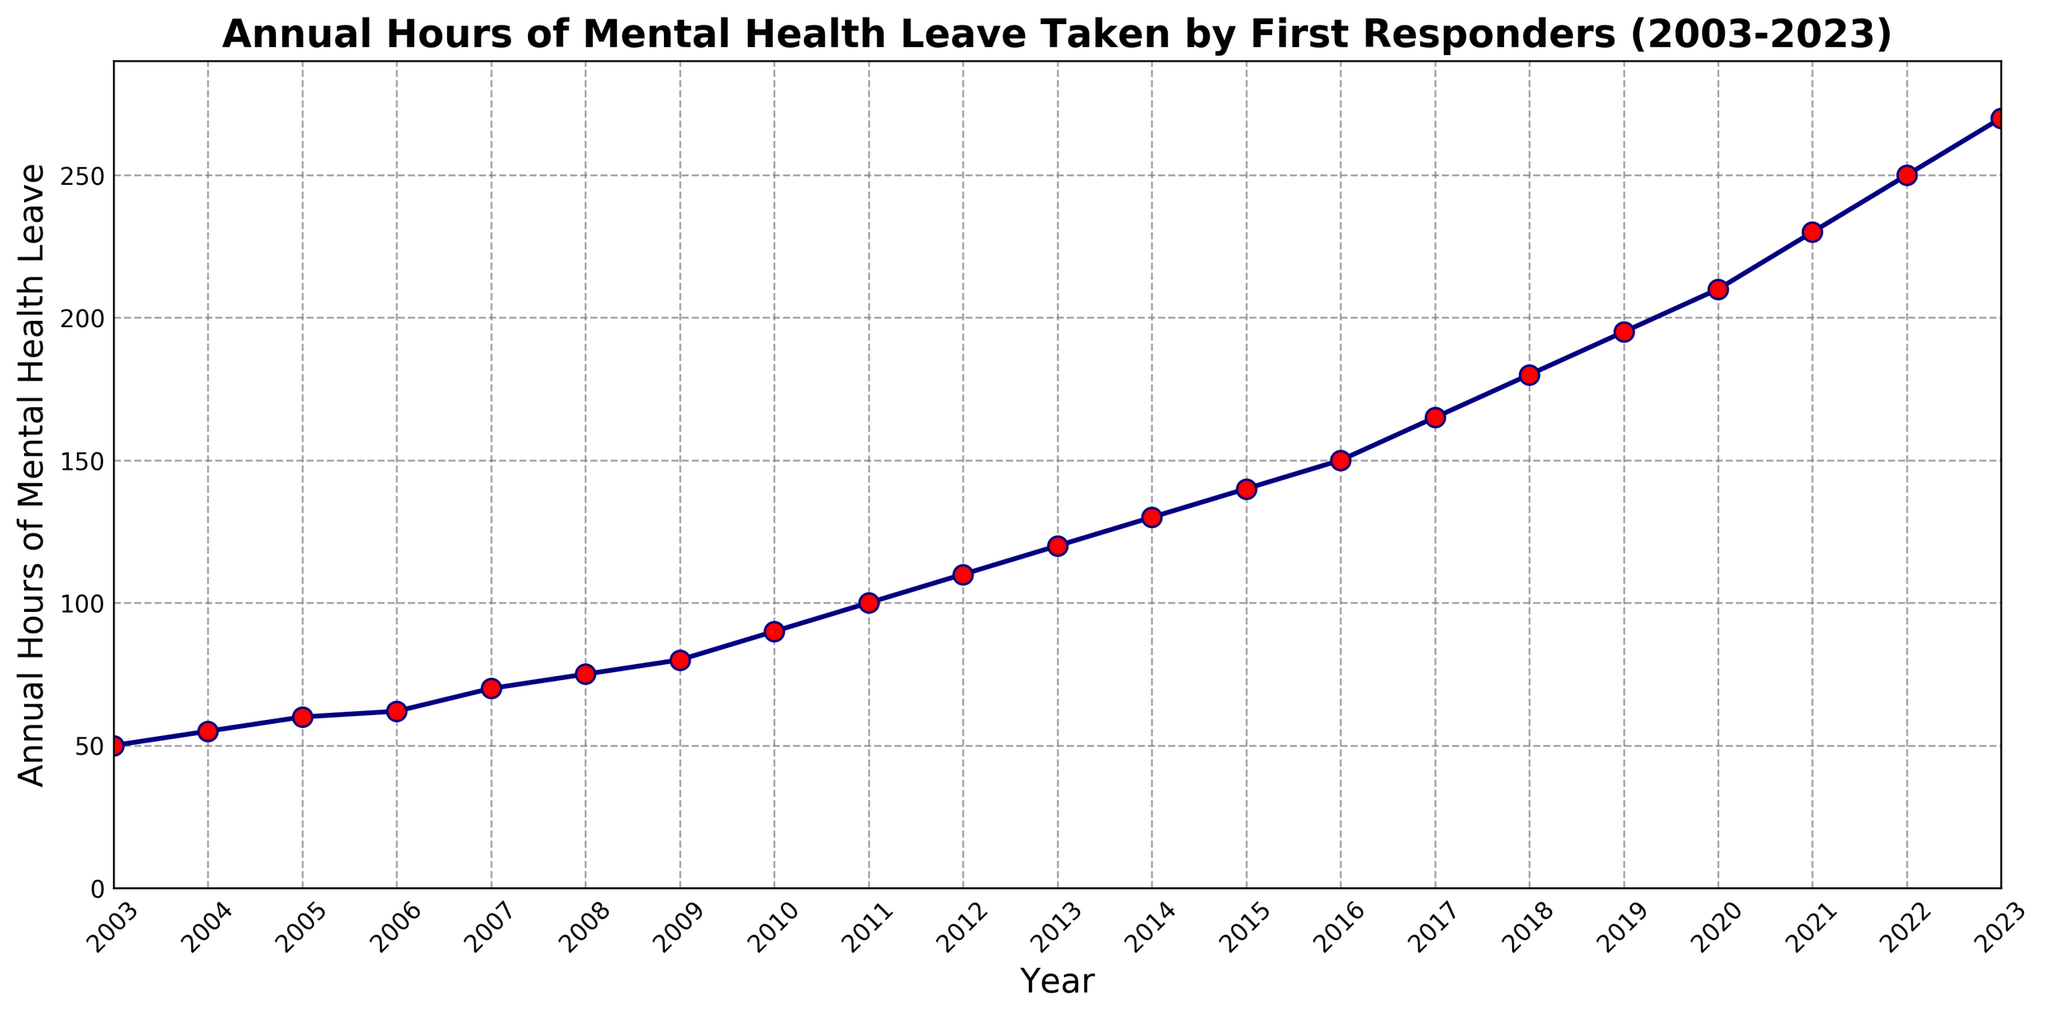What is the general trend in the annual hours of mental health leave taken from 2003 to 2023? The figure shows a continuous upward trend, meaning that the annual hours of mental health leave taken by first responders have been increasing steadily each year from 2003 to 2023.
Answer: Increasing trend Which year had the highest annual hours of mental health leave taken, and what was the value? The highest annual hours of mental health leave were taken in 2023, reaching 270 hours.
Answer: 2023, 270 hours What is the difference in annual hours of mental health leave between 2003 and 2023? The annual hours of mental health leave in 2023 (270 hours) minus the annual hours in 2003 (50 hours) equals 220 hours.
Answer: 220 hours How many years saw an increase of at least 20 hours compared to the previous year? Comparing each year's annual hours to the previous one, the years with an increase of at least 20 hours are 2016, 2018, 2019, 2021, and 2022, making a total of 5 years.
Answer: 5 years Between which consecutive years did the annual hours of mental health leave show the largest increase? The largest increase can be observed between 2009 (80 hours) and 2010 (90 hours), specifically a 10-hour increase. Comparatively, the largest increase of 20 hours between consecutive years occurred between 2022 (250 hours) and 2023 (270 hours).
Answer: 2022 to 2023 How does the increase in annual hours of mental health leave from 2010 to 2015 compare to the increase from 2015 to 2020? From 2010 to 2015, the increase is 140 - 90 = 50 hours. From 2015 to 2020, the increase is 210 - 140 = 70 hours. The increase from 2015 to 2020 is greater.
Answer: 2015 to 2020 What is the average annual hours of mental health leave taken from 2003 to 2023? Sum all the annual hours from 2003 to 2023 and divide by 21. (50+55+60+62+70+75+80+90+100+110+120+130+140+150+165+180+195+210+230+250+270)/21 = 144 hours.
Answer: 144 hours How does the rate of increase in annual hours of mental health leave change before and after 2015? Calculate the slope (rate of change) before and after 2015. Before 2015, (140 - 50) / (2015 - 2003) = 90 / 12 = 7.5 hours/year. After 2015, (270 - 140) / (2023 - 2015) = 130 / 8 = 16.25 hours/year. The rate of increase doubled after 2015.
Answer: Doubled At what rate did the annual hours of mental health leave increase per year on average from 2003 to 2023? Calculate the total increase (270 - 50) and divide by the number of years (2023 - 2003). (270 - 50) / 20 = 220 / 20 = 11 hours/year.
Answer: 11 hours/year Compare the visual trend of annual hours of mental health leave before 2010 and after 2010. The visual trend shows a more gradual increase before 2010 with annual hours increasing by smaller increments. Post-2010, the increments appear larger, showing a steeper upward trend visually represented by a steeper line.
Answer: Steeper increase after 2010 